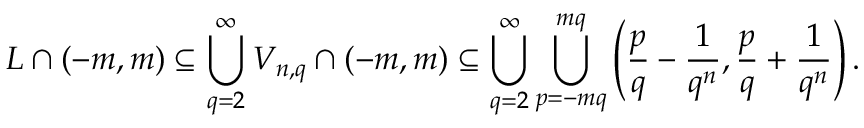Convert formula to latex. <formula><loc_0><loc_0><loc_500><loc_500>L \cap ( - m , m ) \subseteq \bigcup _ { q = 2 } ^ { \infty } V _ { n , q } \cap ( - m , m ) \subseteq \bigcup _ { q = 2 } ^ { \infty } \bigcup _ { p = - m q } ^ { m q } \left ( { \frac { p } { q } } - { \frac { 1 } { q ^ { n } } } , { \frac { p } { q } } + { \frac { 1 } { q ^ { n } } } \right ) .</formula> 